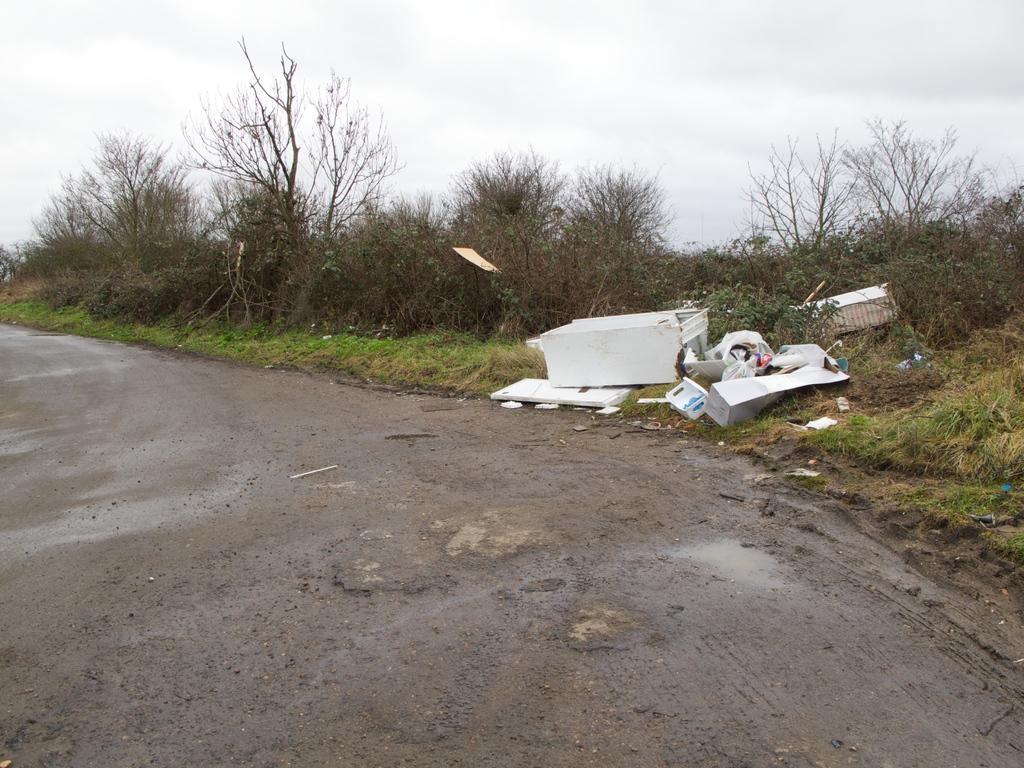Describe this image in one or two sentences. In the picture I can see the road, beside there are some broken boxes, trees, grass. 